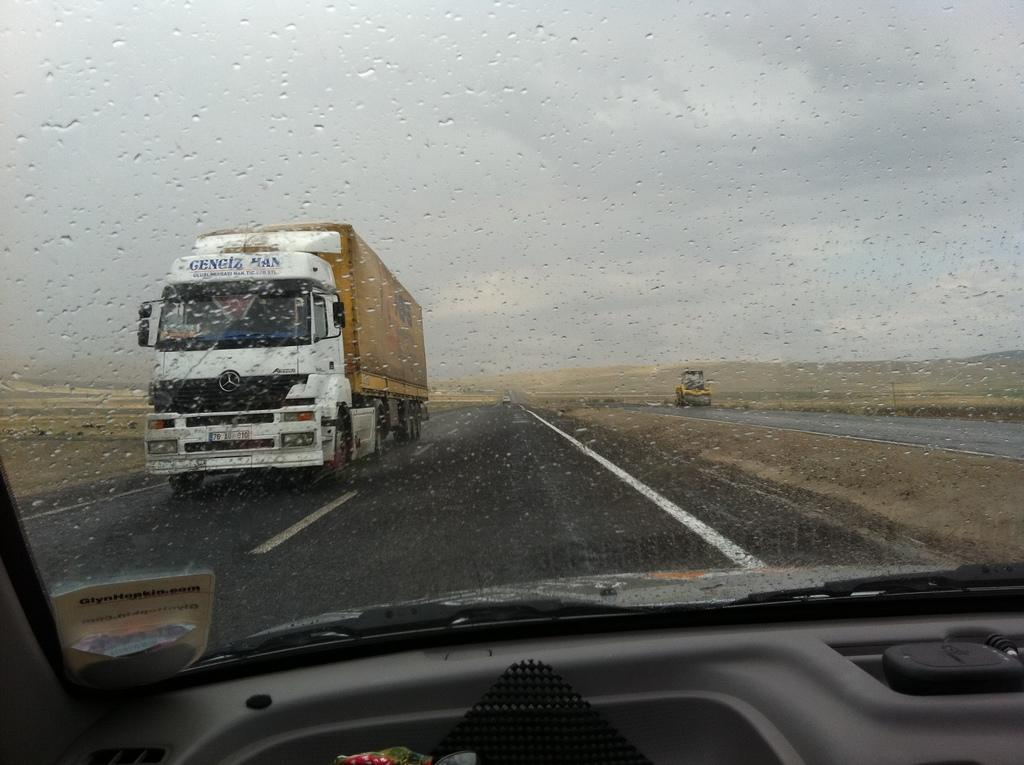What can be seen on the road in the image? There are vehicles on the road in the image. What part of the natural environment is visible in the image? The sky is visible in the background of the image. What type of lettuce is being used as a decoration on the vehicles in the image? There is no lettuce present in the image, and the vehicles are not being decorated with any lettuce. 